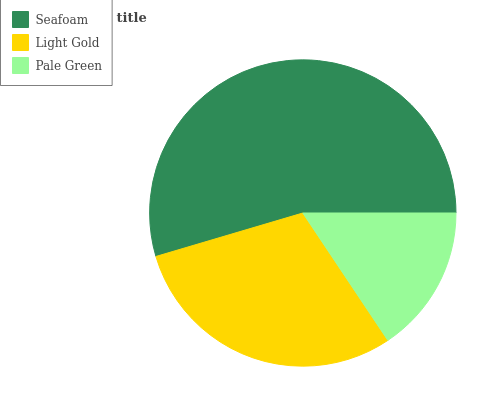Is Pale Green the minimum?
Answer yes or no. Yes. Is Seafoam the maximum?
Answer yes or no. Yes. Is Light Gold the minimum?
Answer yes or no. No. Is Light Gold the maximum?
Answer yes or no. No. Is Seafoam greater than Light Gold?
Answer yes or no. Yes. Is Light Gold less than Seafoam?
Answer yes or no. Yes. Is Light Gold greater than Seafoam?
Answer yes or no. No. Is Seafoam less than Light Gold?
Answer yes or no. No. Is Light Gold the high median?
Answer yes or no. Yes. Is Light Gold the low median?
Answer yes or no. Yes. Is Pale Green the high median?
Answer yes or no. No. Is Pale Green the low median?
Answer yes or no. No. 